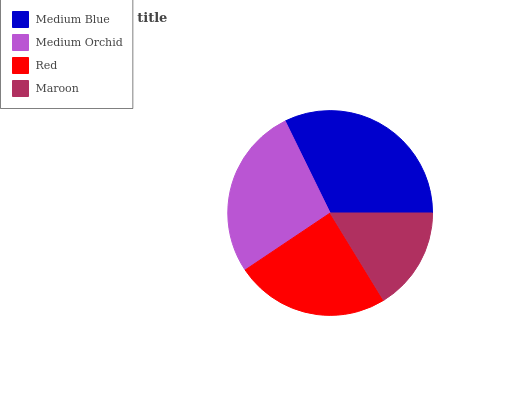Is Maroon the minimum?
Answer yes or no. Yes. Is Medium Blue the maximum?
Answer yes or no. Yes. Is Medium Orchid the minimum?
Answer yes or no. No. Is Medium Orchid the maximum?
Answer yes or no. No. Is Medium Blue greater than Medium Orchid?
Answer yes or no. Yes. Is Medium Orchid less than Medium Blue?
Answer yes or no. Yes. Is Medium Orchid greater than Medium Blue?
Answer yes or no. No. Is Medium Blue less than Medium Orchid?
Answer yes or no. No. Is Medium Orchid the high median?
Answer yes or no. Yes. Is Red the low median?
Answer yes or no. Yes. Is Medium Blue the high median?
Answer yes or no. No. Is Medium Blue the low median?
Answer yes or no. No. 